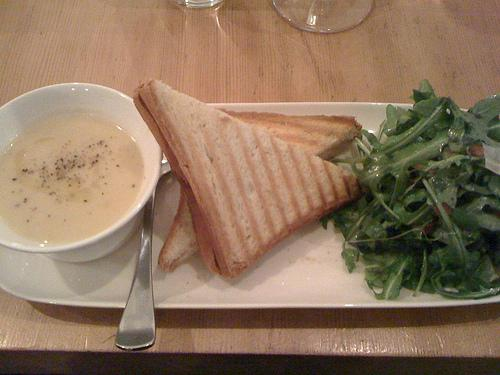Mention the key elements in the image. A wooden table with a large white plate, toasted sandwich, cream soup in a bowl, green leafy salad, silverware, wine glass base, and sprinkled black pepper. Discuss the tableware items found in the image. A silver spoon with a broad edge, a handle of a silver piece of silverware, the rim of a clear glass, and a narrow white ceramic plate. Describe the dipping sauce seen in the image. Yellow dipping sauce is served in a white bowl, with a texture that looks like cream, possibly for the sandwich or the salad. Give a brief description of the dining scene in the image. A meal with a toasted sandwich, soup, and salad is served on a white platter atop a wood grain table setting, accompanied by silverware and a glass. List the food items present on the white plate. Toasted half of sandwich, green leafy salad, hidden tomatoes under leaves, yellow cream sauce in a white bowl, and black pepper on soup. Characterize the salad on the platter. The salad consists of green leafy vegetables, including a bunch of lettuce leaves and oil-covered green arugula, along with hidden tomatoes. Describe the meal served on the plate in the image. The meal consists of a toasted half sandwich, a green leafy salad, and a cream soup in a white bowl, all served on a large white plate. Describe the appearance of the sandwich in the image. The sandwich has toasted bread with grill lines, white and tan pieces of bread, and probably some hidden tomatoes under the top slice. Mention the table settings in the image. A large white plate with food, silver spoon on plate, cream soup in a white bowl, wine glass base, and smooth flat wooden table top. Point out the soup's appearance in the image. Creamy white clam chowder soup with flecks of black pepper on top, served in a white bowl on the left side of the plate. Can you spot the blue handle of the piece of silverware on the table? There is no blue handle in the image. The handle of the silverware is described as silver, not blue. Can you see a green bowl holding yellow sauce in the image? The bowl holding the yellow sauce is described as white, not green. The color attribute is incorrect. Can you find a table covered with a green tablecloth in the image? No, it's not mentioned in the image. Please point out the three grilled cheese sandwich triangles on the plate. There are only two triangles of grilled cheese sandwich mentioned, not three. The quantity attribute is incorrect. Find the chocolate dipping sauce on the left side of the plate. The dipping sauce is described as yellow, not chocolate. The color and flavor attributes are incorrect. Is there a square-shaped white dinner plate in the center of the image? The dinner plate in the image is described as oval-shaped, not square-shaped. The shape attribute is incorrect. Identify the red soup in the black bowl at the top right corner of the image. The soup is described as cream soup (implying it's not red) and is in a white bowl, not a black bowl. Do you notice a golden spoon on the plate with green lettuce leaves? The spoon is described as silver, not golden. The color attribute is incorrect. Observe the clear glass with a rectangular base in the top-right corner. The clear glasses have round bases, not rectangular. The shape attribute is wrong. Notice the purple tomatoes hidden beneath the lettuce leaves? The hidden object under the leaves is described as tomatoes, which are not purple. The color attribute is wrong. 